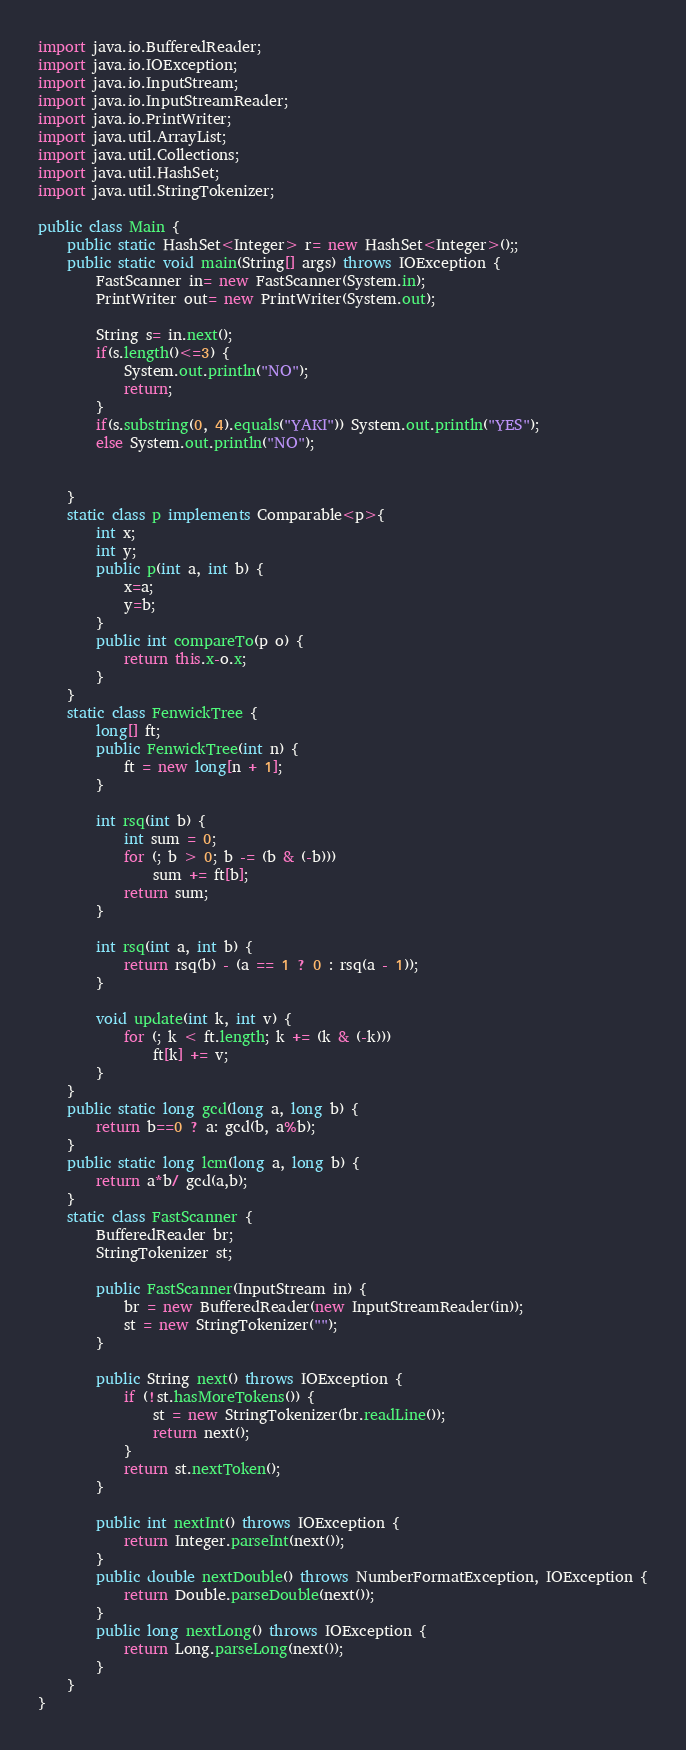<code> <loc_0><loc_0><loc_500><loc_500><_Java_>import java.io.BufferedReader;
import java.io.IOException;
import java.io.InputStream;
import java.io.InputStreamReader;
import java.io.PrintWriter;
import java.util.ArrayList;
import java.util.Collections;
import java.util.HashSet;
import java.util.StringTokenizer;

public class Main {
	public static HashSet<Integer> r= new HashSet<Integer>();;
	public static void main(String[] args) throws IOException {
		FastScanner in= new FastScanner(System.in);
		PrintWriter out= new PrintWriter(System.out);
		
		String s= in.next();
		if(s.length()<=3) {
			System.out.println("NO");
			return;
		}
		if(s.substring(0, 4).equals("YAKI")) System.out.println("YES");
		else System.out.println("NO");
			
		
	}
	static class p implements Comparable<p>{
		int x;
		int y;
		public p(int a, int b) {
			x=a;
			y=b;
		}
		public int compareTo(p o) {
			return this.x-o.x;
		}
	}
	static class FenwickTree {
		long[] ft;
		public FenwickTree(int n) {
			ft = new long[n + 1];
		}

		int rsq(int b) {
			int sum = 0;
			for (; b > 0; b -= (b & (-b)))
				sum += ft[b];
			return sum;
		}

		int rsq(int a, int b) {
			return rsq(b) - (a == 1 ? 0 : rsq(a - 1));
		}

		void update(int k, int v) {
			for (; k < ft.length; k += (k & (-k)))
				ft[k] += v;
		}
	}
	public static long gcd(long a, long b) {
		return b==0 ? a: gcd(b, a%b);
	}
	public static long lcm(long a, long b) {
		return a*b/ gcd(a,b);
	}
	static class FastScanner {
		BufferedReader br;
		StringTokenizer st;

		public FastScanner(InputStream in) {
			br = new BufferedReader(new InputStreamReader(in));
			st = new StringTokenizer("");
		}

		public String next() throws IOException {
			if (!st.hasMoreTokens()) {
				st = new StringTokenizer(br.readLine());
				return next();
			}
			return st.nextToken();
		}

		public int nextInt() throws IOException {
			return Integer.parseInt(next());
		}
		public double nextDouble() throws NumberFormatException, IOException {
			return Double.parseDouble(next());
		}
		public long nextLong() throws IOException {
			return Long.parseLong(next());
		}
	}
}</code> 